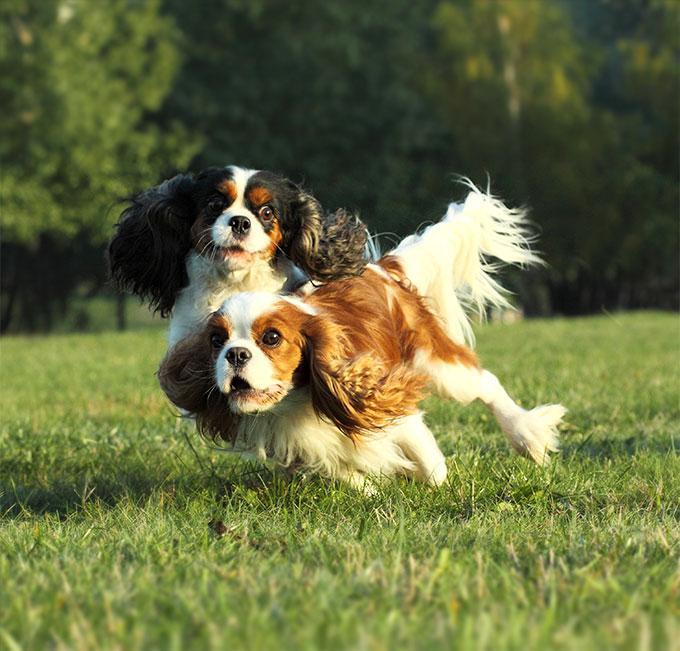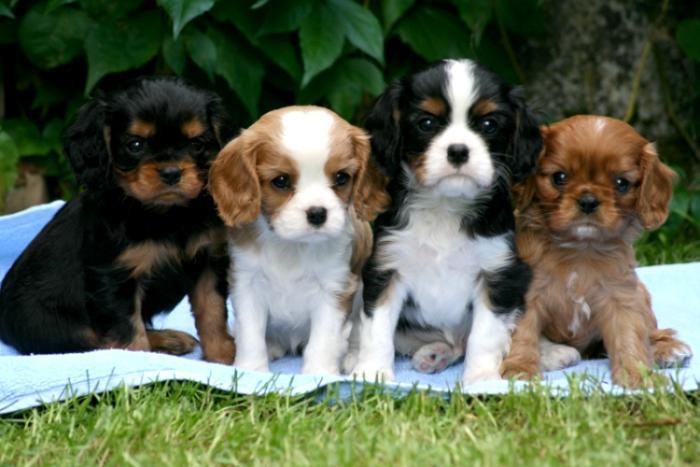The first image is the image on the left, the second image is the image on the right. Considering the images on both sides, is "The right image shows a row of four young dogs." valid? Answer yes or no. Yes. 